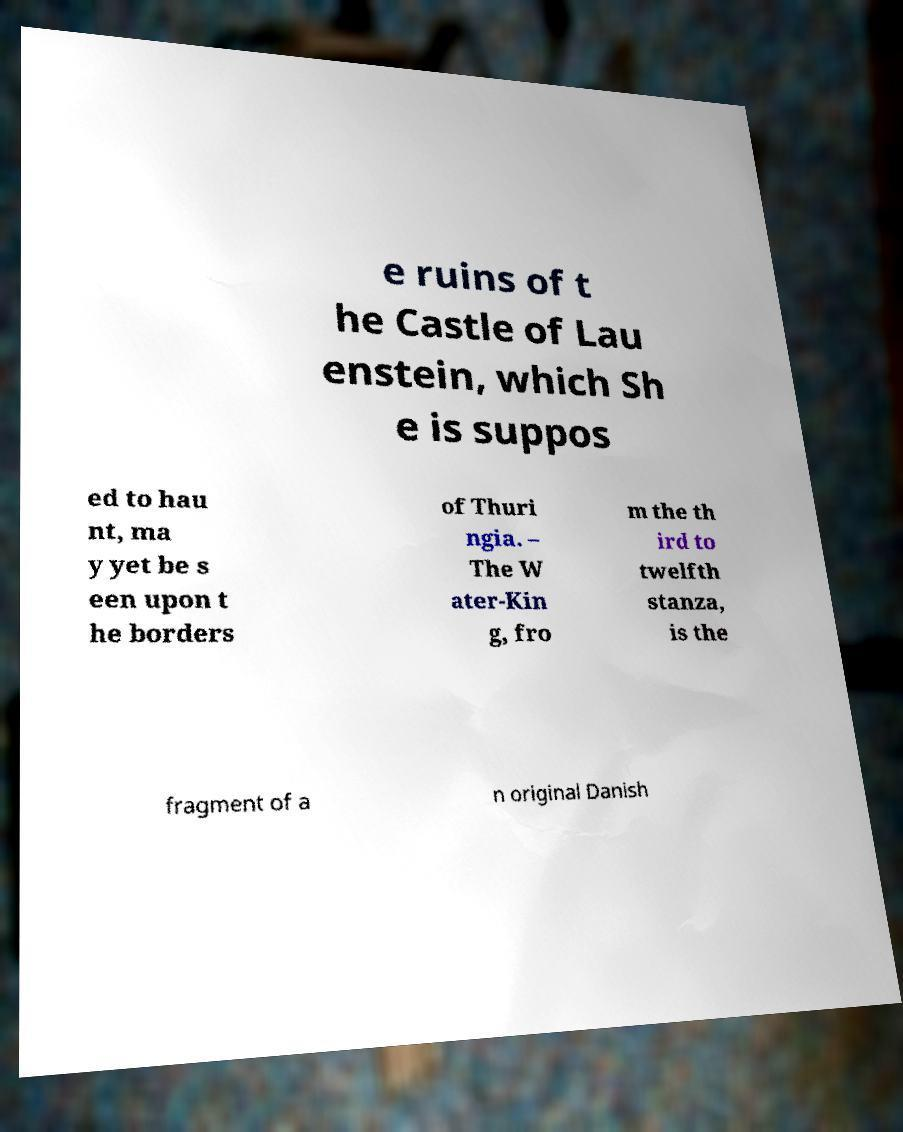For documentation purposes, I need the text within this image transcribed. Could you provide that? e ruins of t he Castle of Lau enstein, which Sh e is suppos ed to hau nt, ma y yet be s een upon t he borders of Thuri ngia. – The W ater-Kin g, fro m the th ird to twelfth stanza, is the fragment of a n original Danish 